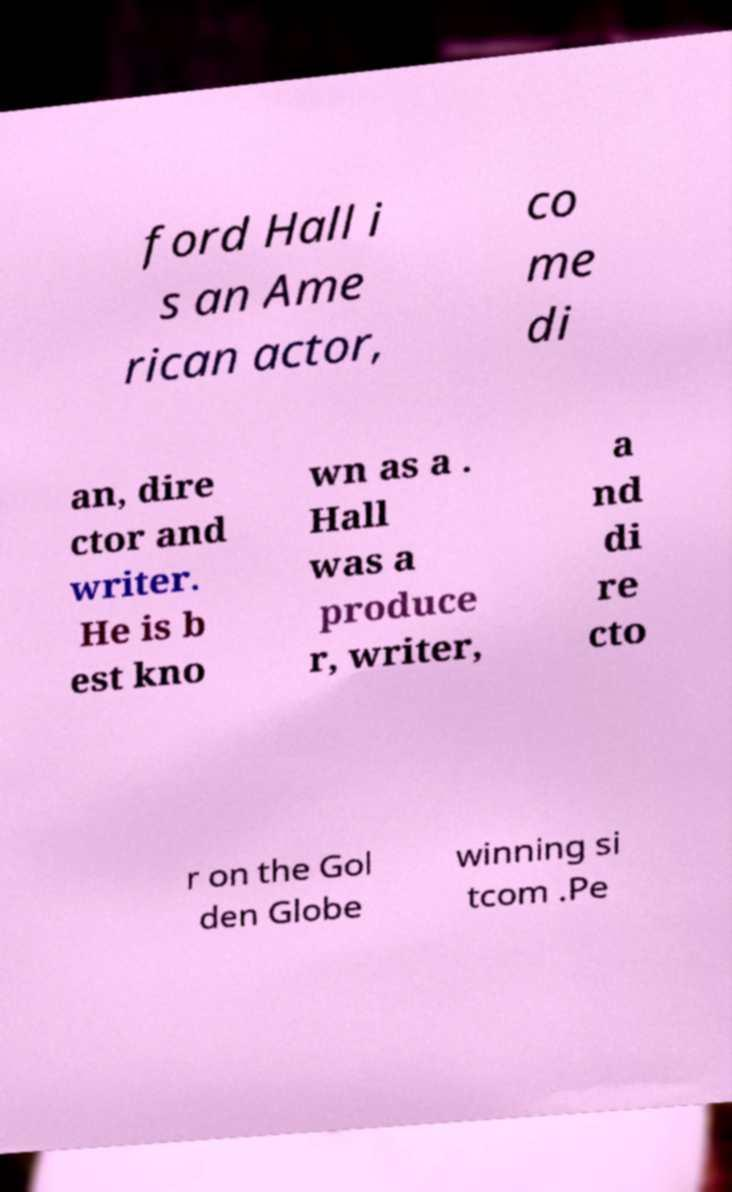I need the written content from this picture converted into text. Can you do that? ford Hall i s an Ame rican actor, co me di an, dire ctor and writer. He is b est kno wn as a . Hall was a produce r, writer, a nd di re cto r on the Gol den Globe winning si tcom .Pe 